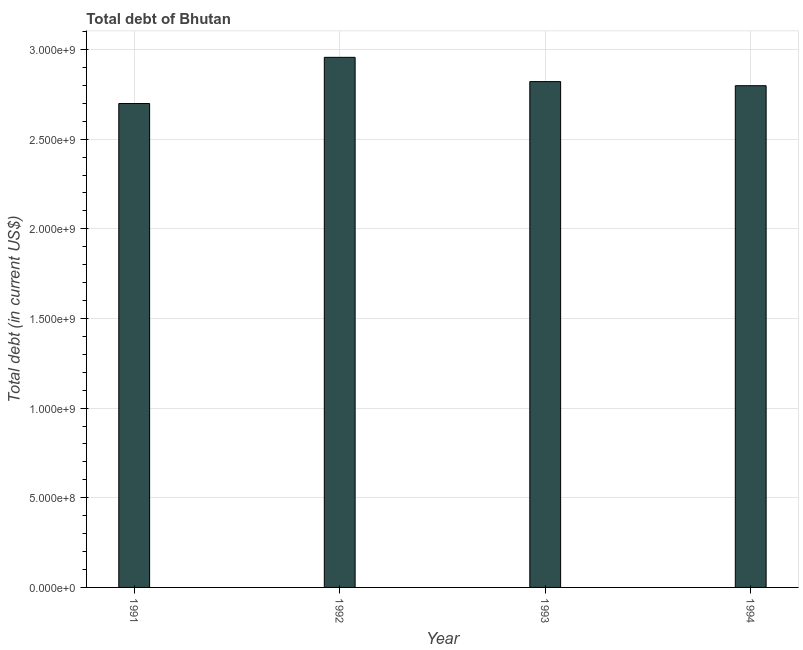Does the graph contain any zero values?
Ensure brevity in your answer.  No. What is the title of the graph?
Provide a short and direct response. Total debt of Bhutan. What is the label or title of the Y-axis?
Provide a short and direct response. Total debt (in current US$). What is the total debt in 1992?
Ensure brevity in your answer.  2.96e+09. Across all years, what is the maximum total debt?
Provide a succinct answer. 2.96e+09. Across all years, what is the minimum total debt?
Your answer should be compact. 2.70e+09. In which year was the total debt minimum?
Ensure brevity in your answer.  1991. What is the sum of the total debt?
Your answer should be compact. 1.13e+1. What is the difference between the total debt in 1991 and 1993?
Give a very brief answer. -1.22e+08. What is the average total debt per year?
Provide a succinct answer. 2.82e+09. What is the median total debt?
Your answer should be compact. 2.81e+09. In how many years, is the total debt greater than 2100000000 US$?
Offer a terse response. 4. Do a majority of the years between 1991 and 1994 (inclusive) have total debt greater than 1600000000 US$?
Provide a succinct answer. Yes. Is the difference between the total debt in 1992 and 1993 greater than the difference between any two years?
Provide a succinct answer. No. What is the difference between the highest and the second highest total debt?
Offer a very short reply. 1.35e+08. Is the sum of the total debt in 1991 and 1992 greater than the maximum total debt across all years?
Your answer should be very brief. Yes. What is the difference between the highest and the lowest total debt?
Provide a short and direct response. 2.58e+08. In how many years, is the total debt greater than the average total debt taken over all years?
Your answer should be compact. 2. Are all the bars in the graph horizontal?
Give a very brief answer. No. How many years are there in the graph?
Ensure brevity in your answer.  4. Are the values on the major ticks of Y-axis written in scientific E-notation?
Your answer should be compact. Yes. What is the Total debt (in current US$) in 1991?
Provide a succinct answer. 2.70e+09. What is the Total debt (in current US$) in 1992?
Your response must be concise. 2.96e+09. What is the Total debt (in current US$) of 1993?
Your answer should be compact. 2.82e+09. What is the Total debt (in current US$) of 1994?
Give a very brief answer. 2.80e+09. What is the difference between the Total debt (in current US$) in 1991 and 1992?
Your answer should be very brief. -2.58e+08. What is the difference between the Total debt (in current US$) in 1991 and 1993?
Keep it short and to the point. -1.22e+08. What is the difference between the Total debt (in current US$) in 1991 and 1994?
Give a very brief answer. -9.93e+07. What is the difference between the Total debt (in current US$) in 1992 and 1993?
Keep it short and to the point. 1.35e+08. What is the difference between the Total debt (in current US$) in 1992 and 1994?
Your answer should be compact. 1.58e+08. What is the difference between the Total debt (in current US$) in 1993 and 1994?
Keep it short and to the point. 2.29e+07. What is the ratio of the Total debt (in current US$) in 1991 to that in 1994?
Offer a very short reply. 0.96. What is the ratio of the Total debt (in current US$) in 1992 to that in 1993?
Ensure brevity in your answer.  1.05. What is the ratio of the Total debt (in current US$) in 1992 to that in 1994?
Your response must be concise. 1.06. What is the ratio of the Total debt (in current US$) in 1993 to that in 1994?
Offer a very short reply. 1.01. 